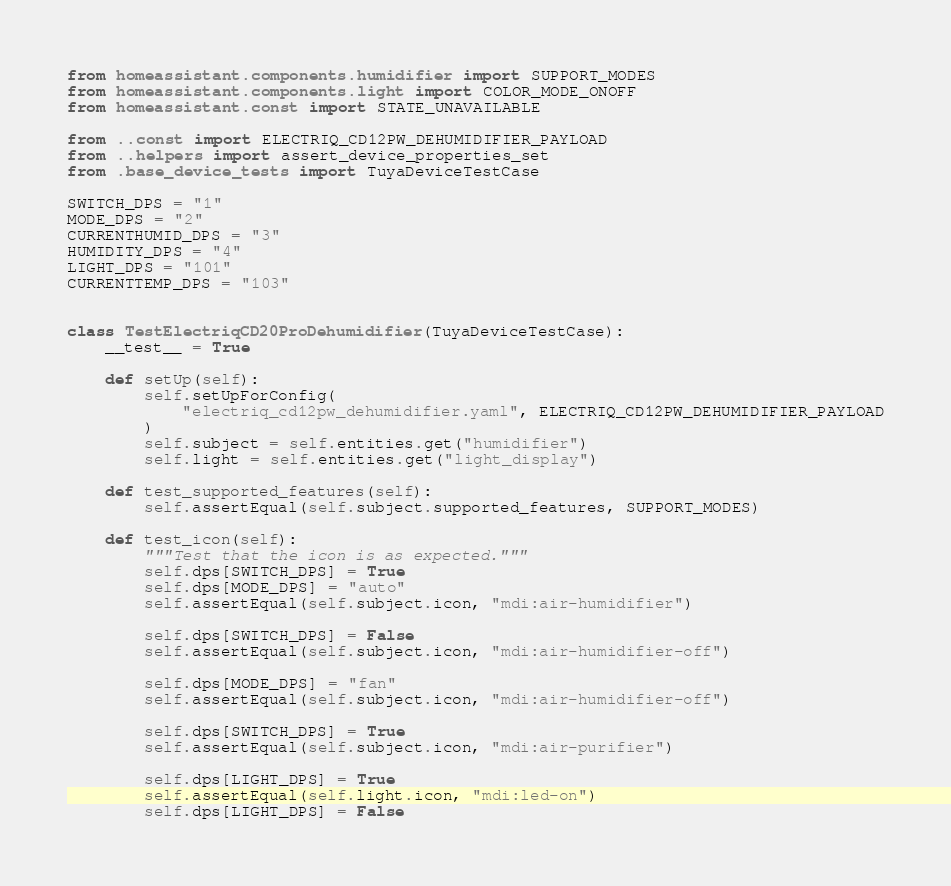Convert code to text. <code><loc_0><loc_0><loc_500><loc_500><_Python_>from homeassistant.components.humidifier import SUPPORT_MODES
from homeassistant.components.light import COLOR_MODE_ONOFF
from homeassistant.const import STATE_UNAVAILABLE

from ..const import ELECTRIQ_CD12PW_DEHUMIDIFIER_PAYLOAD
from ..helpers import assert_device_properties_set
from .base_device_tests import TuyaDeviceTestCase

SWITCH_DPS = "1"
MODE_DPS = "2"
CURRENTHUMID_DPS = "3"
HUMIDITY_DPS = "4"
LIGHT_DPS = "101"
CURRENTTEMP_DPS = "103"


class TestElectriqCD20ProDehumidifier(TuyaDeviceTestCase):
    __test__ = True

    def setUp(self):
        self.setUpForConfig(
            "electriq_cd12pw_dehumidifier.yaml", ELECTRIQ_CD12PW_DEHUMIDIFIER_PAYLOAD
        )
        self.subject = self.entities.get("humidifier")
        self.light = self.entities.get("light_display")

    def test_supported_features(self):
        self.assertEqual(self.subject.supported_features, SUPPORT_MODES)

    def test_icon(self):
        """Test that the icon is as expected."""
        self.dps[SWITCH_DPS] = True
        self.dps[MODE_DPS] = "auto"
        self.assertEqual(self.subject.icon, "mdi:air-humidifier")

        self.dps[SWITCH_DPS] = False
        self.assertEqual(self.subject.icon, "mdi:air-humidifier-off")

        self.dps[MODE_DPS] = "fan"
        self.assertEqual(self.subject.icon, "mdi:air-humidifier-off")

        self.dps[SWITCH_DPS] = True
        self.assertEqual(self.subject.icon, "mdi:air-purifier")

        self.dps[LIGHT_DPS] = True
        self.assertEqual(self.light.icon, "mdi:led-on")
        self.dps[LIGHT_DPS] = False</code> 